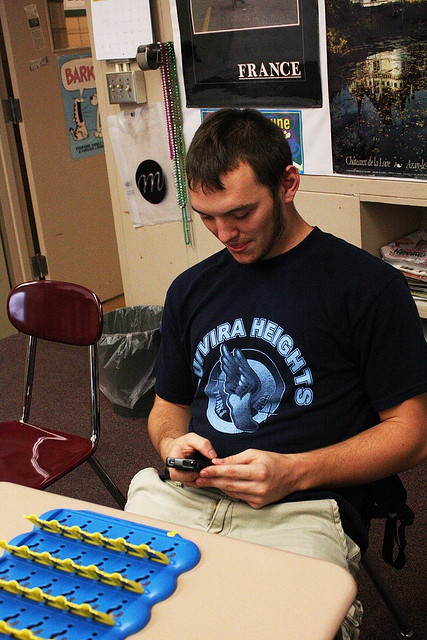Describe the objects in this image and their specific colors. I can see people in brown, black, maroon, and tan tones, dining table in brown, tan, lightblue, and blue tones, chair in brown, maroon, black, and gray tones, and cell phone in brown, black, gray, darkgray, and maroon tones in this image. 